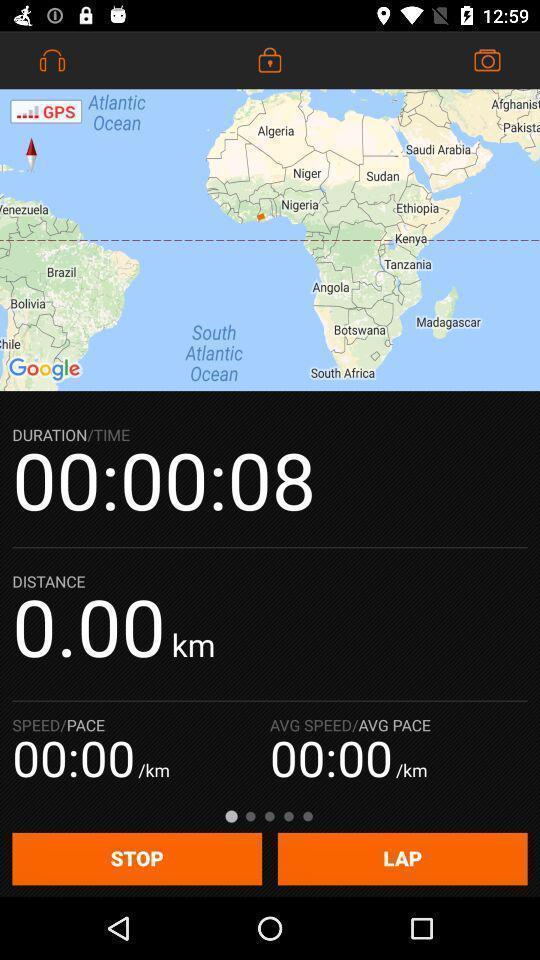Tell me what you see in this picture. Screen showing map with duration time. 